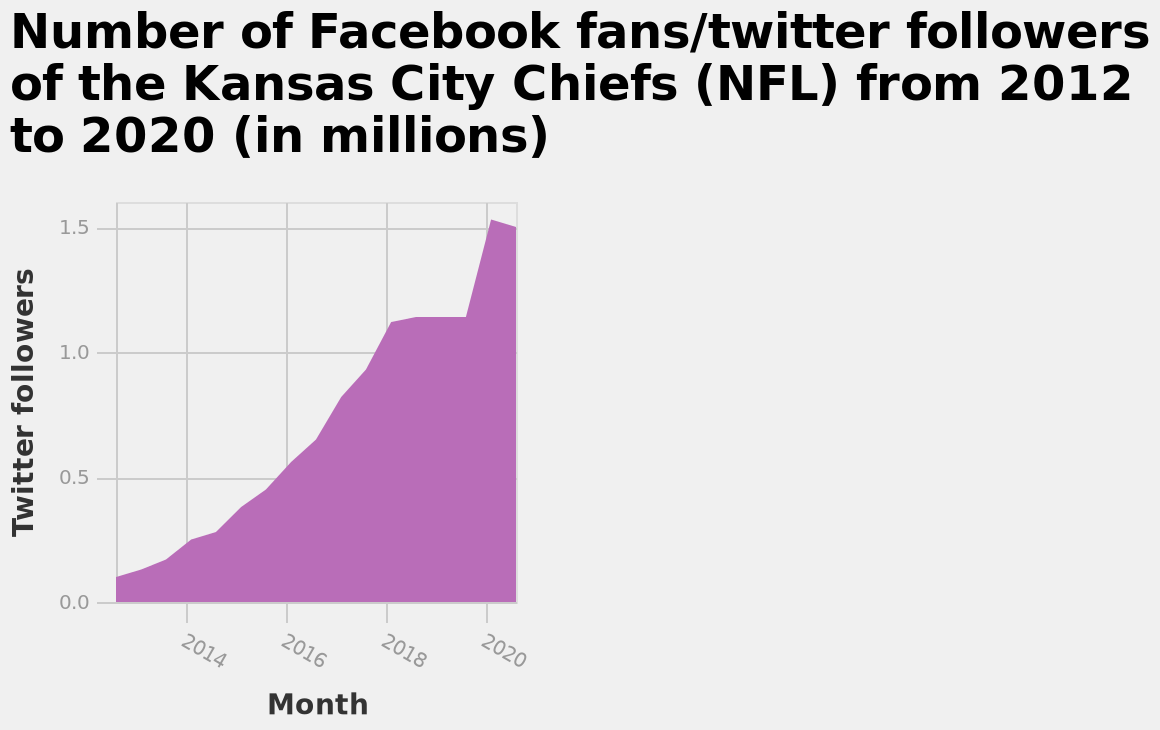<image>
What does the x-axis plot in the area diagram?  The x-axis plots Month. What is the y-axis measure in the area diagram?  The y-axis measures Twitter followers. What is the maximum value on the x-axis in the area diagram? The maximum value on the x-axis is 2020. Why have more people started following the Kansas City Chiefs on social media? More people have started following the Kansas City Chiefs on social media due to better accessibility to technology and an increase in social media account users. 